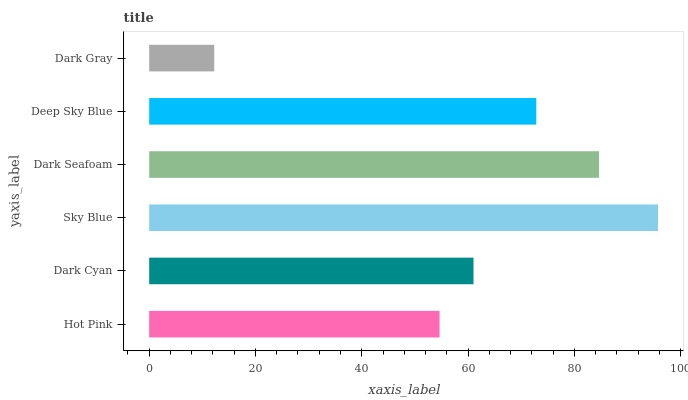Is Dark Gray the minimum?
Answer yes or no. Yes. Is Sky Blue the maximum?
Answer yes or no. Yes. Is Dark Cyan the minimum?
Answer yes or no. No. Is Dark Cyan the maximum?
Answer yes or no. No. Is Dark Cyan greater than Hot Pink?
Answer yes or no. Yes. Is Hot Pink less than Dark Cyan?
Answer yes or no. Yes. Is Hot Pink greater than Dark Cyan?
Answer yes or no. No. Is Dark Cyan less than Hot Pink?
Answer yes or no. No. Is Deep Sky Blue the high median?
Answer yes or no. Yes. Is Dark Cyan the low median?
Answer yes or no. Yes. Is Sky Blue the high median?
Answer yes or no. No. Is Sky Blue the low median?
Answer yes or no. No. 